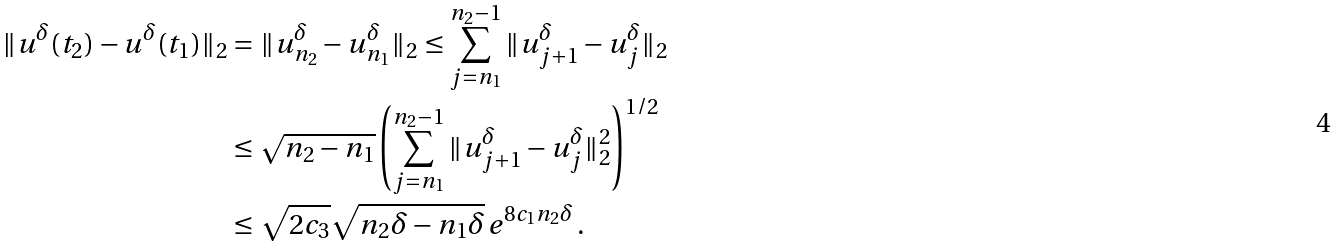<formula> <loc_0><loc_0><loc_500><loc_500>\| u ^ { \delta } ( t _ { 2 } ) - u ^ { \delta } ( t _ { 1 } ) \| _ { 2 } & = \| u ^ { \delta } _ { n _ { 2 } } - u ^ { \delta } _ { n _ { 1 } } \| _ { 2 } \leq \sum _ { j = n _ { 1 } } ^ { n _ { 2 } - 1 } \| u _ { j + 1 } ^ { \delta } - u _ { j } ^ { \delta } \| _ { 2 } \\ & \leq \sqrt { n _ { 2 } - n _ { 1 } } \left ( \sum _ { j = n _ { 1 } } ^ { n _ { 2 } - 1 } \| u _ { j + 1 } ^ { \delta } - u _ { j } ^ { \delta } \| _ { 2 } ^ { 2 } \right ) ^ { 1 / 2 } \\ & \leq \sqrt { 2 c _ { 3 } } \sqrt { n _ { 2 } \delta - n _ { 1 } \delta } \, e ^ { 8 c _ { 1 } n _ { 2 } \delta } \, .</formula> 